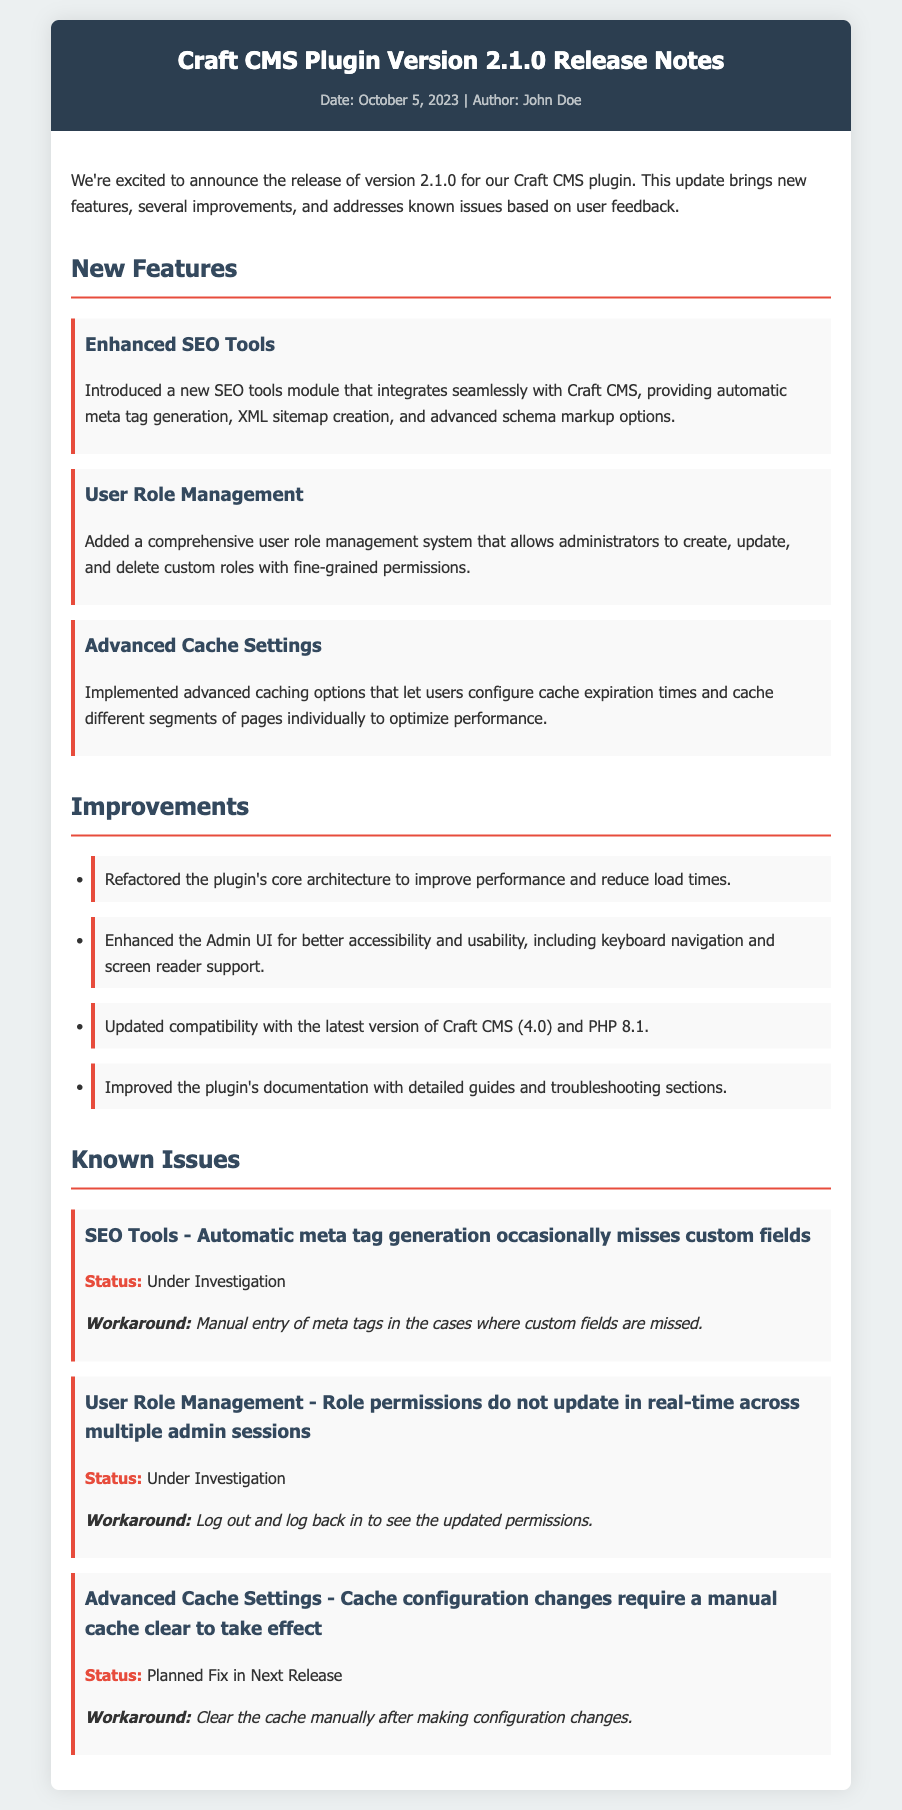What is the version number of the plugin? The version number is mentioned in the title of the document.
Answer: 2.1.0 Who is the author of the release notes? The author is listed at the top of the document under the metadata section.
Answer: John Doe What date was the release announced? The date is provided in the metadata section of the header.
Answer: October 5, 2023 How many new features are listed in the document? The number of new features can be counted in the New Features section.
Answer: 3 Which issue is under investigation related to SEO Tools? The issue regarding SEO Tools is stated specifically in the Known Issues section.
Answer: Automatic meta tag generation occasionally misses custom fields What is a workaround for the User Role Management issue? The workaround is provided in the Known Issues section under the specific issue.
Answer: Log out and log back in to see the updated permissions What major compatibility update does the plugin include? The compatibility update is mentioned in the Improvements section.
Answer: PHP 8.1 How is the Admin UI improved? The improvements for the Admin UI are detailed in the Improvements section.
Answer: Better accessibility and usability What is the status of the cache configuration changes issue? The status of the issue is explicitly stated in the Known Issues section.
Answer: Planned Fix in Next Release 